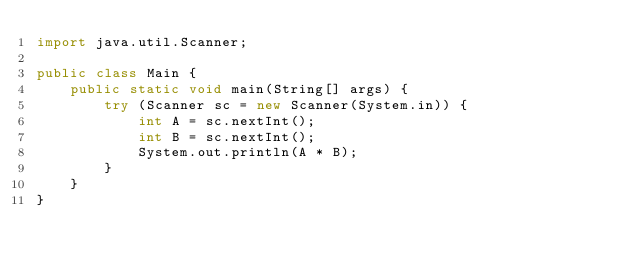<code> <loc_0><loc_0><loc_500><loc_500><_Java_>import java.util.Scanner;

public class Main {
    public static void main(String[] args) {
        try (Scanner sc = new Scanner(System.in)) {
            int A = sc.nextInt();
            int B = sc.nextInt();
            System.out.println(A * B);
        }
    }
}
</code> 